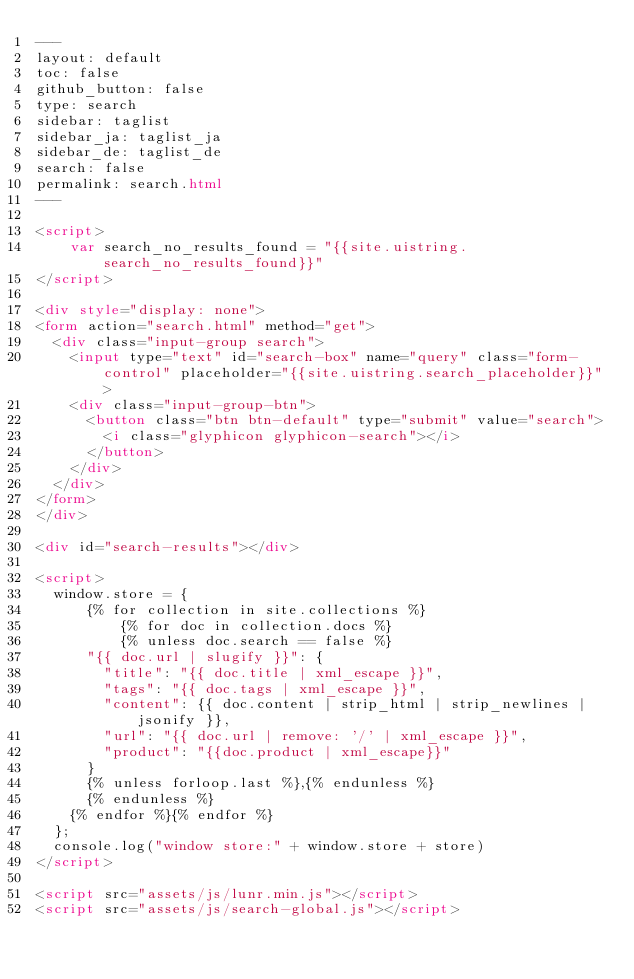<code> <loc_0><loc_0><loc_500><loc_500><_HTML_>---
layout: default
toc: false
github_button: false
type: search
sidebar: taglist
sidebar_ja: taglist_ja
sidebar_de: taglist_de
search: false
permalink: search.html
---

<script>
    var search_no_results_found = "{{site.uistring.search_no_results_found}}"
</script>

<div style="display: none">
<form action="search.html" method="get">
  <div class="input-group search">
    <input type="text" id="search-box" name="query" class="form-control" placeholder="{{site.uistring.search_placeholder}}">
    <div class="input-group-btn">
      <button class="btn btn-default" type="submit" value="search">
        <i class="glyphicon glyphicon-search"></i>
      </button>
    </div>
  </div>
</form>
</div>

<div id="search-results"></div>

<script>
  window.store = {
      {% for collection in site.collections %}
          {% for doc in collection.docs %}
          {% unless doc.search == false %}
      "{{ doc.url | slugify }}": {
        "title": "{{ doc.title | xml_escape }}",
        "tags": "{{ doc.tags | xml_escape }}",
        "content": {{ doc.content | strip_html | strip_newlines | jsonify }},
        "url": "{{ doc.url | remove: '/' | xml_escape }}",
        "product": "{{doc.product | xml_escape}}"
      }
      {% unless forloop.last %},{% endunless %}
      {% endunless %}
    {% endfor %}{% endfor %}
  };
  console.log("window store:" + window.store + store)
</script>

<script src="assets/js/lunr.min.js"></script>
<script src="assets/js/search-global.js"></script>


</code> 